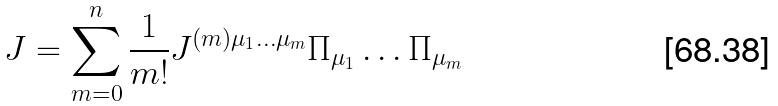<formula> <loc_0><loc_0><loc_500><loc_500>J = \sum _ { m = 0 } ^ { n } \frac { 1 } { m ! } J ^ { ( m ) \mu _ { 1 } \dots \mu _ { m } } \Pi _ { \mu _ { 1 } } \dots \Pi _ { \mu _ { m } }</formula> 